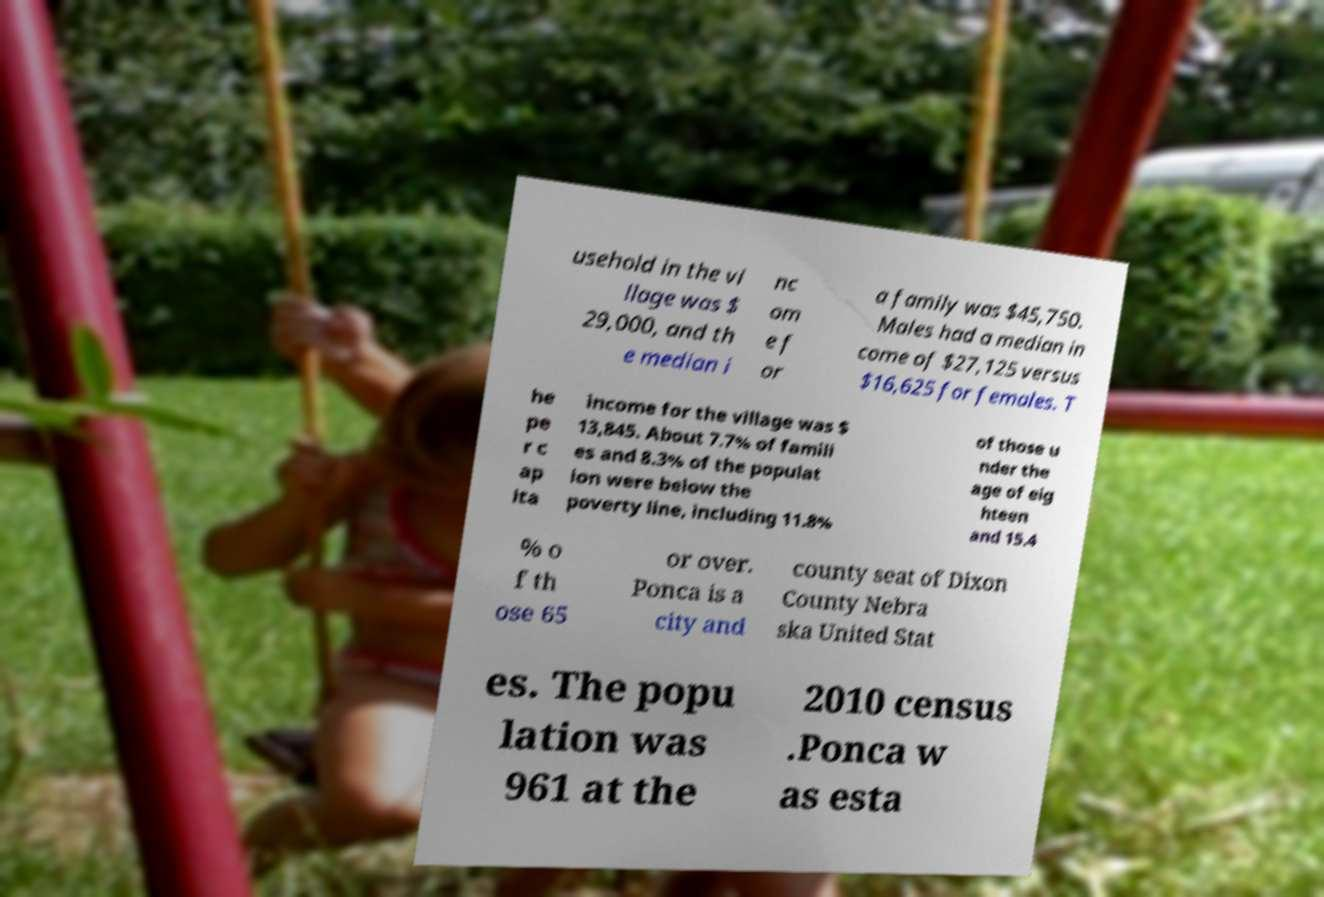Could you extract and type out the text from this image? usehold in the vi llage was $ 29,000, and th e median i nc om e f or a family was $45,750. Males had a median in come of $27,125 versus $16,625 for females. T he pe r c ap ita income for the village was $ 13,845. About 7.7% of famili es and 8.3% of the populat ion were below the poverty line, including 11.8% of those u nder the age of eig hteen and 15.4 % o f th ose 65 or over. Ponca is a city and county seat of Dixon County Nebra ska United Stat es. The popu lation was 961 at the 2010 census .Ponca w as esta 